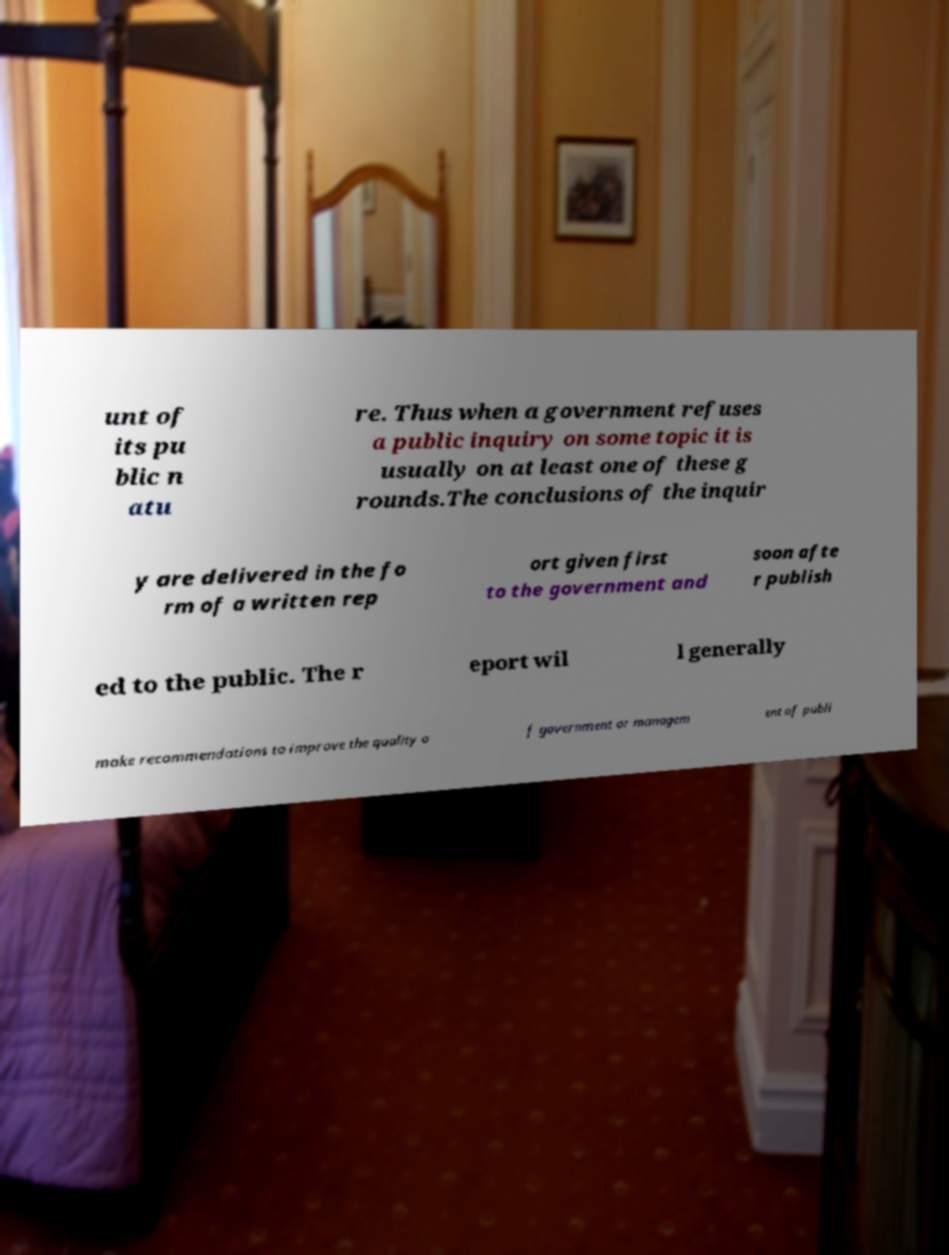Please read and relay the text visible in this image. What does it say? unt of its pu blic n atu re. Thus when a government refuses a public inquiry on some topic it is usually on at least one of these g rounds.The conclusions of the inquir y are delivered in the fo rm of a written rep ort given first to the government and soon afte r publish ed to the public. The r eport wil l generally make recommendations to improve the quality o f government or managem ent of publi 